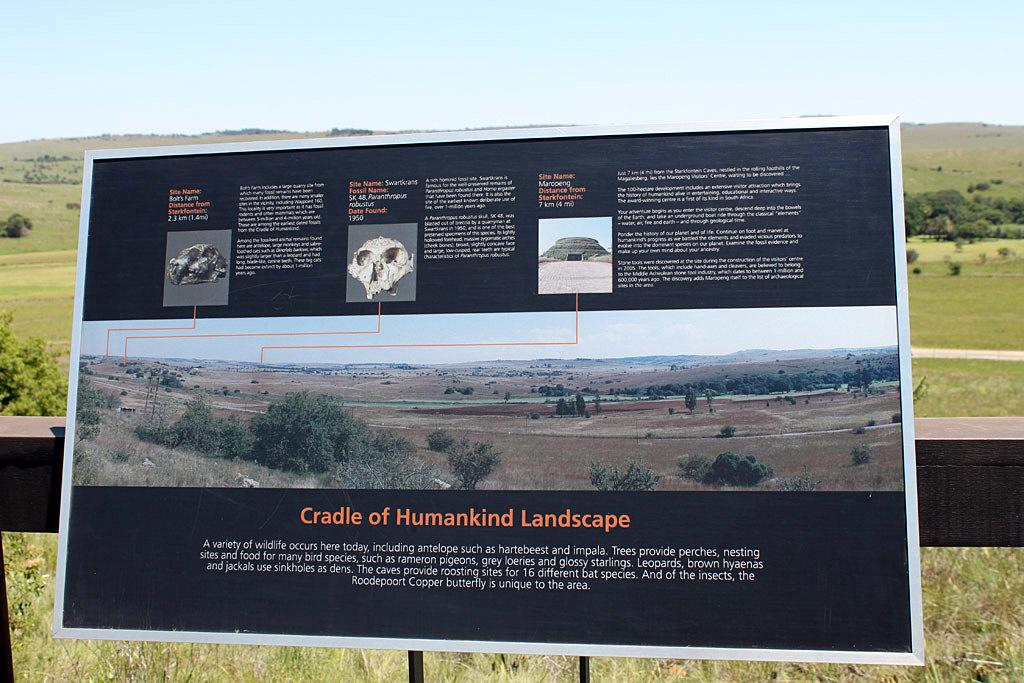Provide a one-sentence caption for the provided image. Cradle of Humankind landscape poster on the outside. 